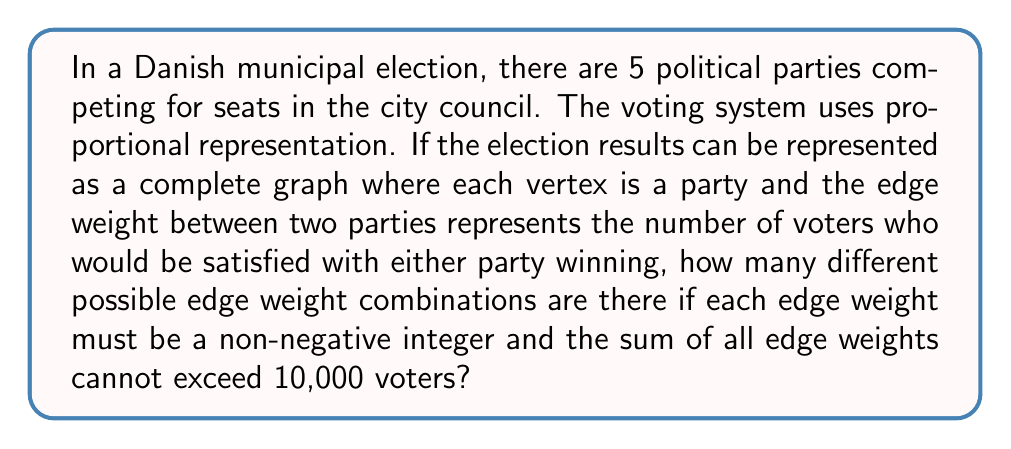Can you solve this math problem? Let's approach this step-by-step:

1) First, we need to determine how many edges are in a complete graph with 5 vertices. The formula for this is:

   $$\text{Number of edges} = \frac{n(n-1)}{2}$$

   Where $n$ is the number of vertices. So:

   $$\text{Number of edges} = \frac{5(5-1)}{2} = \frac{5 \cdot 4}{2} = 10$$

2) Now, we have 10 edges, each of which can have a non-negative integer weight, and the sum of all weights must not exceed 10,000.

3) This is a classic stars and bars problem in combinatorics. We can think of it as distributing 10,000 indistinguishable balls (voters) into 11 distinguishable boxes (10 edges + 1 extra box for the remaining voters to reach 10,000).

4) The formula for this combination is:

   $$\binom{n+k-1}{k-1}$$

   Where $n$ is the number of objects (10,000 voters) and $k$ is the number of boxes (11).

5) Plugging in our values:

   $$\binom{10000+11-1}{11-1} = \binom{10010}{10}$$

6) This can be calculated as:

   $$\frac{10010!}{10! \cdot 10000!}$$

7) The result of this calculation is a very large number: 2,755,351,751,786,015,770
Answer: 2,755,351,751,786,015,770 